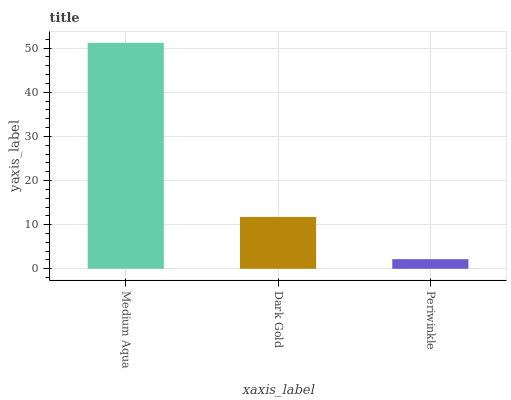Is Periwinkle the minimum?
Answer yes or no. Yes. Is Medium Aqua the maximum?
Answer yes or no. Yes. Is Dark Gold the minimum?
Answer yes or no. No. Is Dark Gold the maximum?
Answer yes or no. No. Is Medium Aqua greater than Dark Gold?
Answer yes or no. Yes. Is Dark Gold less than Medium Aqua?
Answer yes or no. Yes. Is Dark Gold greater than Medium Aqua?
Answer yes or no. No. Is Medium Aqua less than Dark Gold?
Answer yes or no. No. Is Dark Gold the high median?
Answer yes or no. Yes. Is Dark Gold the low median?
Answer yes or no. Yes. Is Medium Aqua the high median?
Answer yes or no. No. Is Medium Aqua the low median?
Answer yes or no. No. 